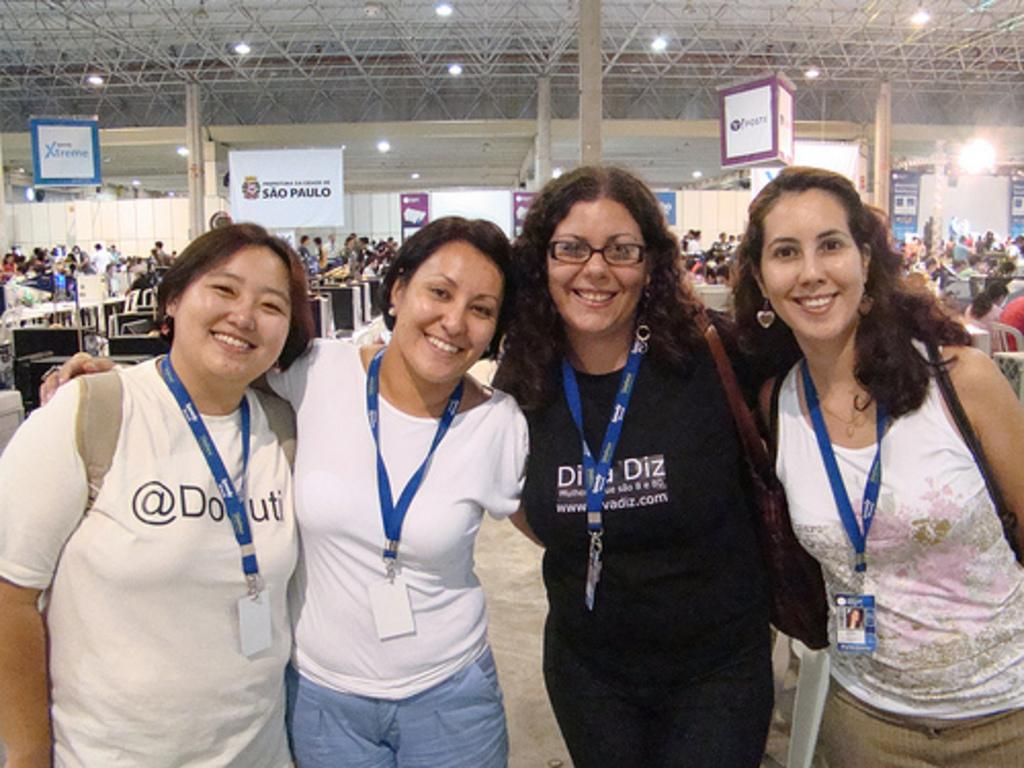<image>
Give a short and clear explanation of the subsequent image. a group of women posing with one wearing an @ symbol 